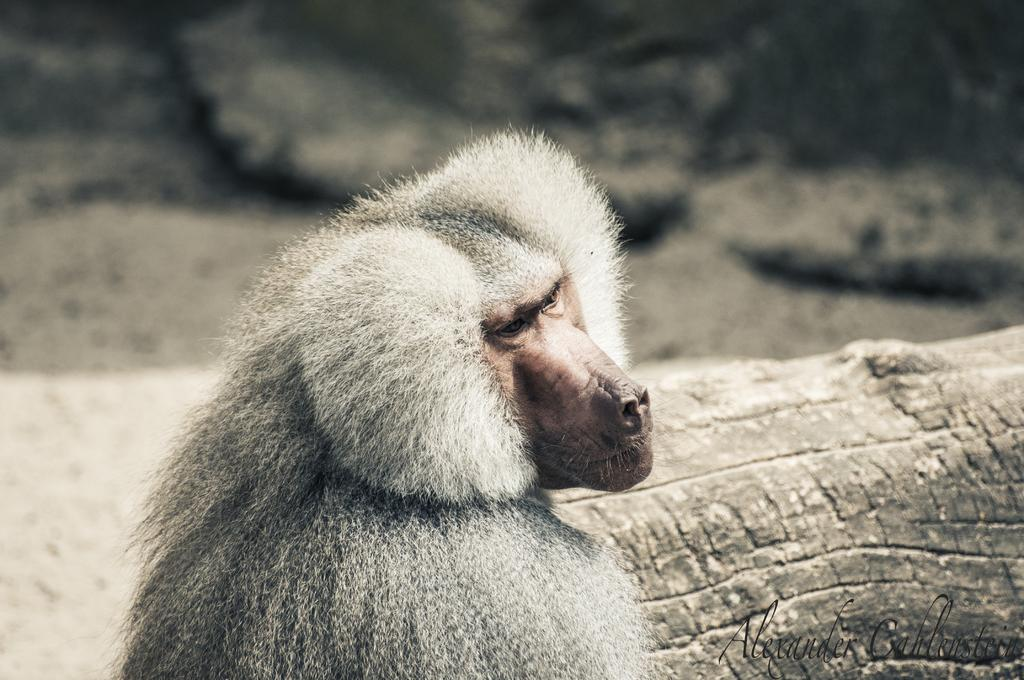What is the main subject in the center of the image? There is an animal in the center of the image. What other objects can be seen in the image? There is a log in the image. What type of natural elements are visible in the background? There are rocks in the background of the image. Is there any text present in the image? Yes, there is some text at the bottom of the image. Can you describe the sand dunes in the image? There are no sand dunes present in the image. 